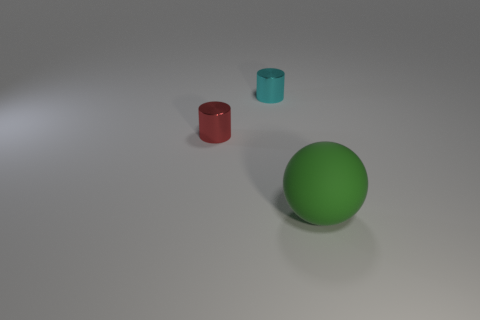What is the color of the large matte thing? The large matte object in the image is a sphere with a smooth surface and a vibrant green color. 